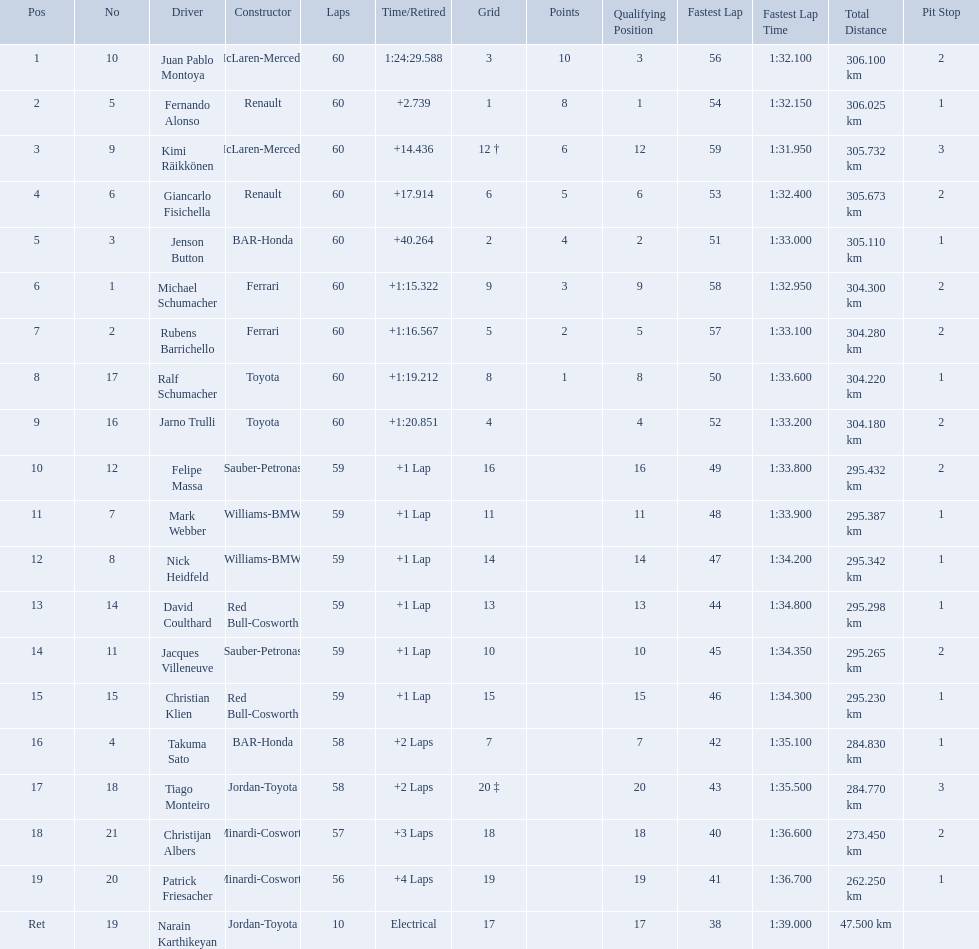Which driver has his grid at 2? Jenson Button. 